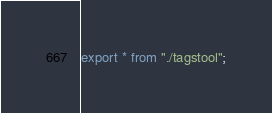Convert code to text. <code><loc_0><loc_0><loc_500><loc_500><_TypeScript_>export * from "./tagstool";
</code> 